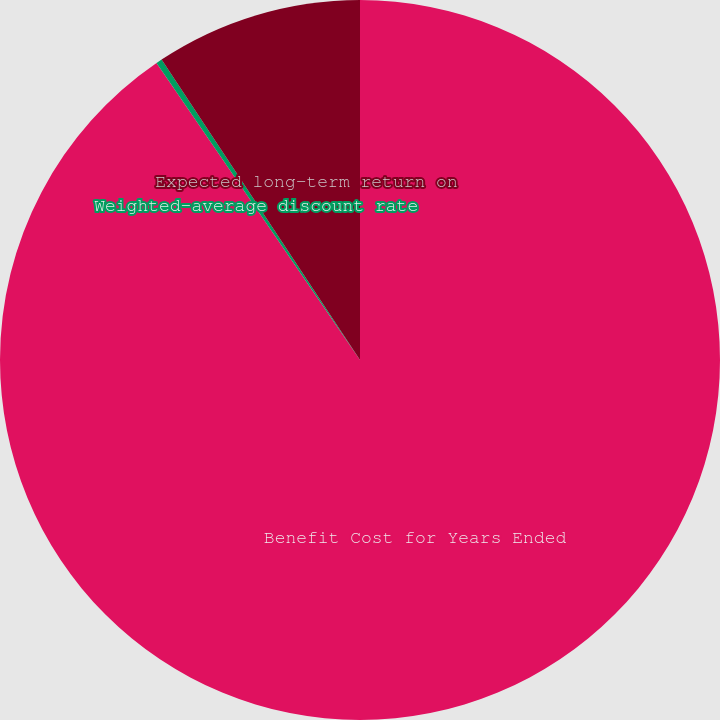<chart> <loc_0><loc_0><loc_500><loc_500><pie_chart><fcel>Benefit Cost for Years Ended<fcel>Weighted-average discount rate<fcel>Expected long-term return on<nl><fcel>90.44%<fcel>0.27%<fcel>9.29%<nl></chart> 